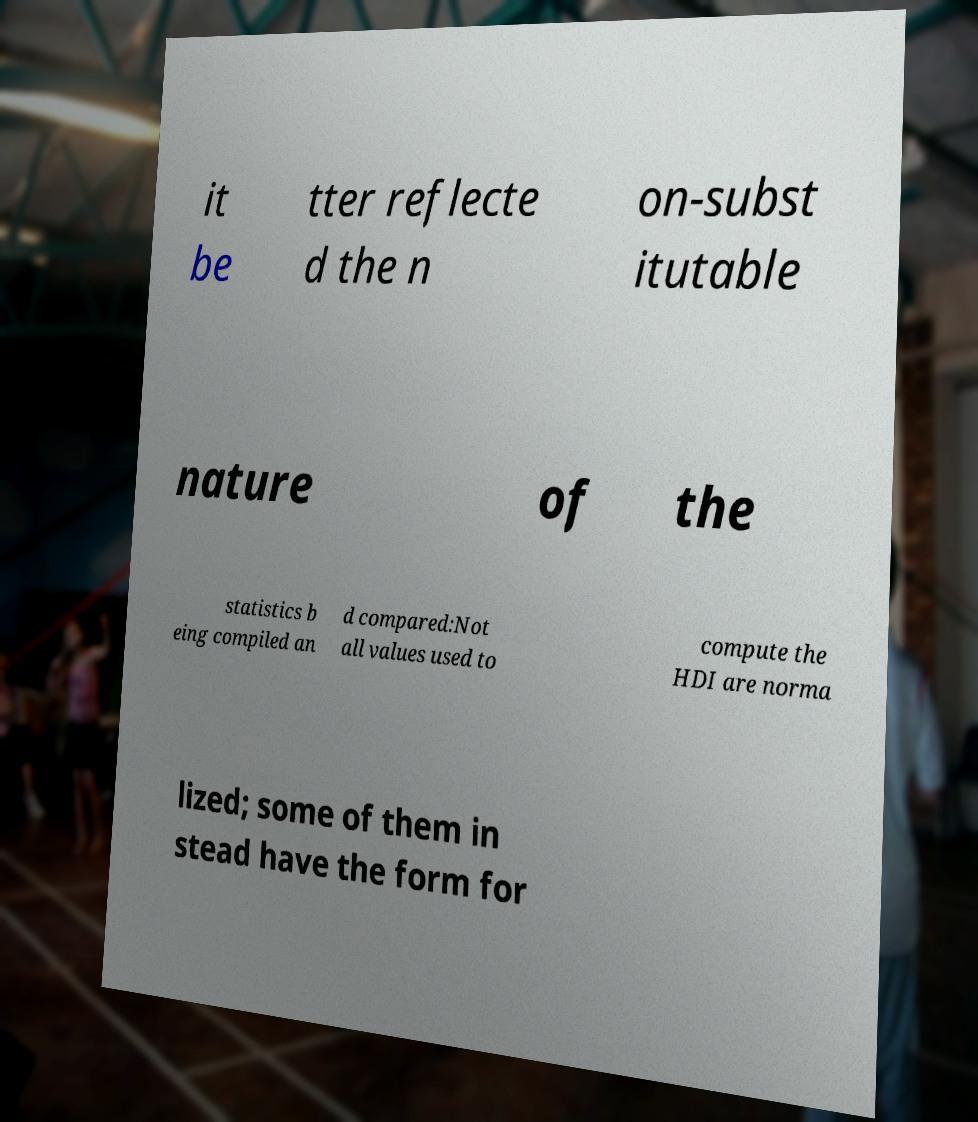There's text embedded in this image that I need extracted. Can you transcribe it verbatim? it be tter reflecte d the n on-subst itutable nature of the statistics b eing compiled an d compared:Not all values used to compute the HDI are norma lized; some of them in stead have the form for 